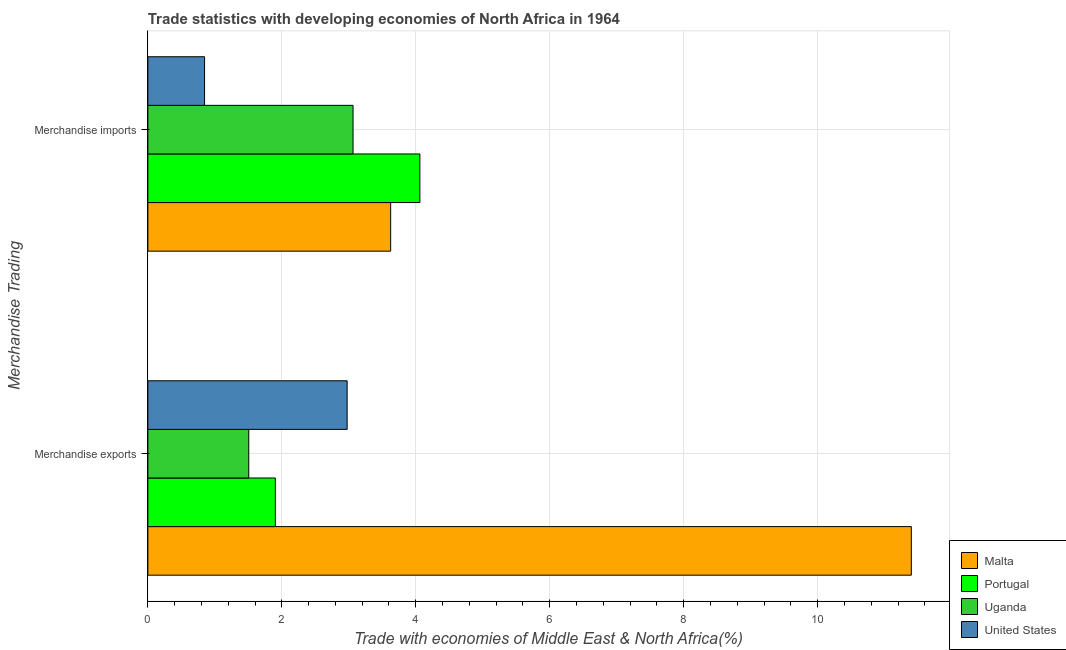Are the number of bars per tick equal to the number of legend labels?
Give a very brief answer. Yes. Are the number of bars on each tick of the Y-axis equal?
Provide a short and direct response. Yes. What is the merchandise imports in Malta?
Make the answer very short. 3.63. Across all countries, what is the maximum merchandise imports?
Give a very brief answer. 4.06. Across all countries, what is the minimum merchandise imports?
Provide a short and direct response. 0.85. In which country was the merchandise exports minimum?
Keep it short and to the point. Uganda. What is the total merchandise imports in the graph?
Offer a terse response. 11.6. What is the difference between the merchandise imports in United States and that in Malta?
Your response must be concise. -2.78. What is the difference between the merchandise exports in Portugal and the merchandise imports in Uganda?
Keep it short and to the point. -1.16. What is the average merchandise exports per country?
Give a very brief answer. 4.45. What is the difference between the merchandise exports and merchandise imports in Portugal?
Your answer should be very brief. -2.16. In how many countries, is the merchandise exports greater than 8.4 %?
Provide a succinct answer. 1. What is the ratio of the merchandise exports in Malta to that in Portugal?
Keep it short and to the point. 5.99. Is the merchandise exports in United States less than that in Malta?
Offer a very short reply. Yes. How many bars are there?
Provide a short and direct response. 8. Are all the bars in the graph horizontal?
Offer a terse response. Yes. What is the difference between two consecutive major ticks on the X-axis?
Provide a succinct answer. 2. Does the graph contain grids?
Your response must be concise. Yes. What is the title of the graph?
Your answer should be compact. Trade statistics with developing economies of North Africa in 1964. What is the label or title of the X-axis?
Provide a succinct answer. Trade with economies of Middle East & North Africa(%). What is the label or title of the Y-axis?
Your answer should be compact. Merchandise Trading. What is the Trade with economies of Middle East & North Africa(%) in Malta in Merchandise exports?
Offer a very short reply. 11.4. What is the Trade with economies of Middle East & North Africa(%) in Portugal in Merchandise exports?
Provide a short and direct response. 1.9. What is the Trade with economies of Middle East & North Africa(%) of Uganda in Merchandise exports?
Give a very brief answer. 1.51. What is the Trade with economies of Middle East & North Africa(%) in United States in Merchandise exports?
Offer a terse response. 2.98. What is the Trade with economies of Middle East & North Africa(%) of Malta in Merchandise imports?
Your answer should be compact. 3.63. What is the Trade with economies of Middle East & North Africa(%) of Portugal in Merchandise imports?
Make the answer very short. 4.06. What is the Trade with economies of Middle East & North Africa(%) of Uganda in Merchandise imports?
Offer a terse response. 3.06. What is the Trade with economies of Middle East & North Africa(%) in United States in Merchandise imports?
Make the answer very short. 0.85. Across all Merchandise Trading, what is the maximum Trade with economies of Middle East & North Africa(%) of Malta?
Make the answer very short. 11.4. Across all Merchandise Trading, what is the maximum Trade with economies of Middle East & North Africa(%) in Portugal?
Give a very brief answer. 4.06. Across all Merchandise Trading, what is the maximum Trade with economies of Middle East & North Africa(%) in Uganda?
Ensure brevity in your answer.  3.06. Across all Merchandise Trading, what is the maximum Trade with economies of Middle East & North Africa(%) in United States?
Ensure brevity in your answer.  2.98. Across all Merchandise Trading, what is the minimum Trade with economies of Middle East & North Africa(%) of Malta?
Your answer should be compact. 3.63. Across all Merchandise Trading, what is the minimum Trade with economies of Middle East & North Africa(%) in Portugal?
Your answer should be compact. 1.9. Across all Merchandise Trading, what is the minimum Trade with economies of Middle East & North Africa(%) in Uganda?
Provide a short and direct response. 1.51. Across all Merchandise Trading, what is the minimum Trade with economies of Middle East & North Africa(%) in United States?
Offer a terse response. 0.85. What is the total Trade with economies of Middle East & North Africa(%) of Malta in the graph?
Provide a succinct answer. 15.02. What is the total Trade with economies of Middle East & North Africa(%) in Portugal in the graph?
Give a very brief answer. 5.96. What is the total Trade with economies of Middle East & North Africa(%) of Uganda in the graph?
Make the answer very short. 4.57. What is the total Trade with economies of Middle East & North Africa(%) in United States in the graph?
Offer a very short reply. 3.82. What is the difference between the Trade with economies of Middle East & North Africa(%) in Malta in Merchandise exports and that in Merchandise imports?
Your answer should be compact. 7.77. What is the difference between the Trade with economies of Middle East & North Africa(%) in Portugal in Merchandise exports and that in Merchandise imports?
Make the answer very short. -2.16. What is the difference between the Trade with economies of Middle East & North Africa(%) of Uganda in Merchandise exports and that in Merchandise imports?
Give a very brief answer. -1.56. What is the difference between the Trade with economies of Middle East & North Africa(%) of United States in Merchandise exports and that in Merchandise imports?
Keep it short and to the point. 2.13. What is the difference between the Trade with economies of Middle East & North Africa(%) of Malta in Merchandise exports and the Trade with economies of Middle East & North Africa(%) of Portugal in Merchandise imports?
Offer a terse response. 7.34. What is the difference between the Trade with economies of Middle East & North Africa(%) of Malta in Merchandise exports and the Trade with economies of Middle East & North Africa(%) of Uganda in Merchandise imports?
Offer a terse response. 8.34. What is the difference between the Trade with economies of Middle East & North Africa(%) in Malta in Merchandise exports and the Trade with economies of Middle East & North Africa(%) in United States in Merchandise imports?
Give a very brief answer. 10.55. What is the difference between the Trade with economies of Middle East & North Africa(%) in Portugal in Merchandise exports and the Trade with economies of Middle East & North Africa(%) in Uganda in Merchandise imports?
Your response must be concise. -1.16. What is the difference between the Trade with economies of Middle East & North Africa(%) in Portugal in Merchandise exports and the Trade with economies of Middle East & North Africa(%) in United States in Merchandise imports?
Your response must be concise. 1.06. What is the difference between the Trade with economies of Middle East & North Africa(%) in Uganda in Merchandise exports and the Trade with economies of Middle East & North Africa(%) in United States in Merchandise imports?
Provide a short and direct response. 0.66. What is the average Trade with economies of Middle East & North Africa(%) of Malta per Merchandise Trading?
Give a very brief answer. 7.51. What is the average Trade with economies of Middle East & North Africa(%) in Portugal per Merchandise Trading?
Offer a very short reply. 2.98. What is the average Trade with economies of Middle East & North Africa(%) of Uganda per Merchandise Trading?
Ensure brevity in your answer.  2.28. What is the average Trade with economies of Middle East & North Africa(%) in United States per Merchandise Trading?
Offer a very short reply. 1.91. What is the difference between the Trade with economies of Middle East & North Africa(%) in Malta and Trade with economies of Middle East & North Africa(%) in Portugal in Merchandise exports?
Keep it short and to the point. 9.5. What is the difference between the Trade with economies of Middle East & North Africa(%) of Malta and Trade with economies of Middle East & North Africa(%) of Uganda in Merchandise exports?
Offer a very short reply. 9.89. What is the difference between the Trade with economies of Middle East & North Africa(%) of Malta and Trade with economies of Middle East & North Africa(%) of United States in Merchandise exports?
Your answer should be very brief. 8.42. What is the difference between the Trade with economies of Middle East & North Africa(%) of Portugal and Trade with economies of Middle East & North Africa(%) of Uganda in Merchandise exports?
Your answer should be very brief. 0.4. What is the difference between the Trade with economies of Middle East & North Africa(%) in Portugal and Trade with economies of Middle East & North Africa(%) in United States in Merchandise exports?
Keep it short and to the point. -1.07. What is the difference between the Trade with economies of Middle East & North Africa(%) in Uganda and Trade with economies of Middle East & North Africa(%) in United States in Merchandise exports?
Offer a very short reply. -1.47. What is the difference between the Trade with economies of Middle East & North Africa(%) of Malta and Trade with economies of Middle East & North Africa(%) of Portugal in Merchandise imports?
Make the answer very short. -0.44. What is the difference between the Trade with economies of Middle East & North Africa(%) in Malta and Trade with economies of Middle East & North Africa(%) in Uganda in Merchandise imports?
Make the answer very short. 0.56. What is the difference between the Trade with economies of Middle East & North Africa(%) in Malta and Trade with economies of Middle East & North Africa(%) in United States in Merchandise imports?
Your response must be concise. 2.78. What is the difference between the Trade with economies of Middle East & North Africa(%) of Portugal and Trade with economies of Middle East & North Africa(%) of Uganda in Merchandise imports?
Make the answer very short. 1. What is the difference between the Trade with economies of Middle East & North Africa(%) of Portugal and Trade with economies of Middle East & North Africa(%) of United States in Merchandise imports?
Your answer should be very brief. 3.21. What is the difference between the Trade with economies of Middle East & North Africa(%) of Uganda and Trade with economies of Middle East & North Africa(%) of United States in Merchandise imports?
Your answer should be very brief. 2.22. What is the ratio of the Trade with economies of Middle East & North Africa(%) in Malta in Merchandise exports to that in Merchandise imports?
Your answer should be compact. 3.14. What is the ratio of the Trade with economies of Middle East & North Africa(%) of Portugal in Merchandise exports to that in Merchandise imports?
Make the answer very short. 0.47. What is the ratio of the Trade with economies of Middle East & North Africa(%) in Uganda in Merchandise exports to that in Merchandise imports?
Make the answer very short. 0.49. What is the ratio of the Trade with economies of Middle East & North Africa(%) of United States in Merchandise exports to that in Merchandise imports?
Provide a succinct answer. 3.51. What is the difference between the highest and the second highest Trade with economies of Middle East & North Africa(%) in Malta?
Your response must be concise. 7.77. What is the difference between the highest and the second highest Trade with economies of Middle East & North Africa(%) in Portugal?
Keep it short and to the point. 2.16. What is the difference between the highest and the second highest Trade with economies of Middle East & North Africa(%) of Uganda?
Make the answer very short. 1.56. What is the difference between the highest and the second highest Trade with economies of Middle East & North Africa(%) of United States?
Give a very brief answer. 2.13. What is the difference between the highest and the lowest Trade with economies of Middle East & North Africa(%) of Malta?
Ensure brevity in your answer.  7.77. What is the difference between the highest and the lowest Trade with economies of Middle East & North Africa(%) of Portugal?
Provide a succinct answer. 2.16. What is the difference between the highest and the lowest Trade with economies of Middle East & North Africa(%) in Uganda?
Offer a terse response. 1.56. What is the difference between the highest and the lowest Trade with economies of Middle East & North Africa(%) in United States?
Your answer should be very brief. 2.13. 